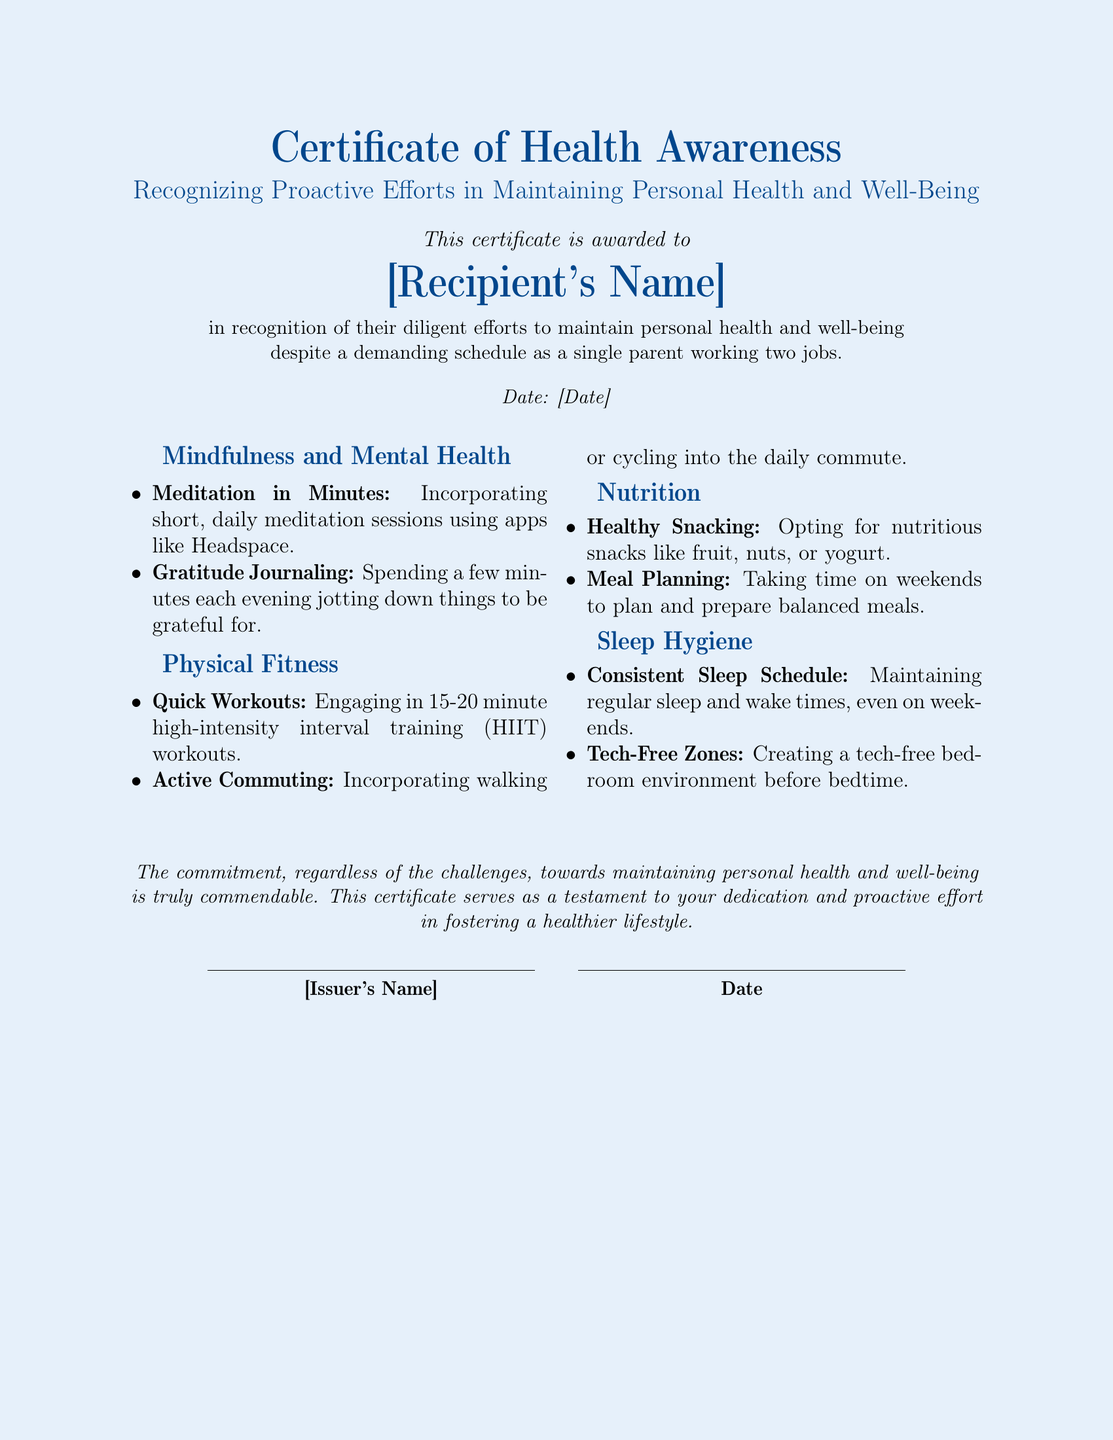What is the title of the document? The title is prominently displayed at the top of the document, stating the purpose of the certificate.
Answer: Certificate of Health Awareness Who is the certificate awarded to? The recipient's name is specified after the statement of recognition.
Answer: [Recipient's Name] What are the two main categories included under Mindfulness and Mental Health? The categories mentioned in the document are part of a list under that section.
Answer: Meditation in Minutes and Gratitude Journaling What date is mentioned on the certificate? The date is indicated at the bottom near the issuer's name.
Answer: [Date] How long are the recommended quick workouts? The document specifies the duration of the workouts under Physical Fitness.
Answer: 15-20 minutes What types of snacks are recommended for healthy eating? The types of snacks are provided in a list under the Nutrition section.
Answer: Fruit, nuts, or yogurt What is one strategy suggested for improving sleep hygiene? The document provides actionable strategies under that section.
Answer: Consistent Sleep Schedule What does the certificate recognize? The purpose of the certificate is detailed in the introduction.
Answer: Proactive Efforts in Maintaining Personal Health and Well-Being 